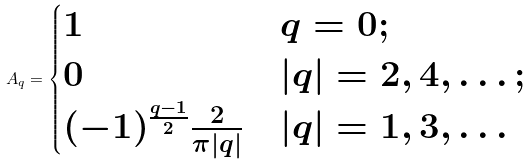<formula> <loc_0><loc_0><loc_500><loc_500>A _ { q } = \begin{cases} 1 & q = 0 ; \\ 0 & | q | = 2 , 4 , \dots ; \\ ( - 1 ) ^ { \frac { q - 1 } { 2 } } \frac { 2 } { \pi | q | } & | q | = 1 , 3 , \dots \end{cases}</formula> 